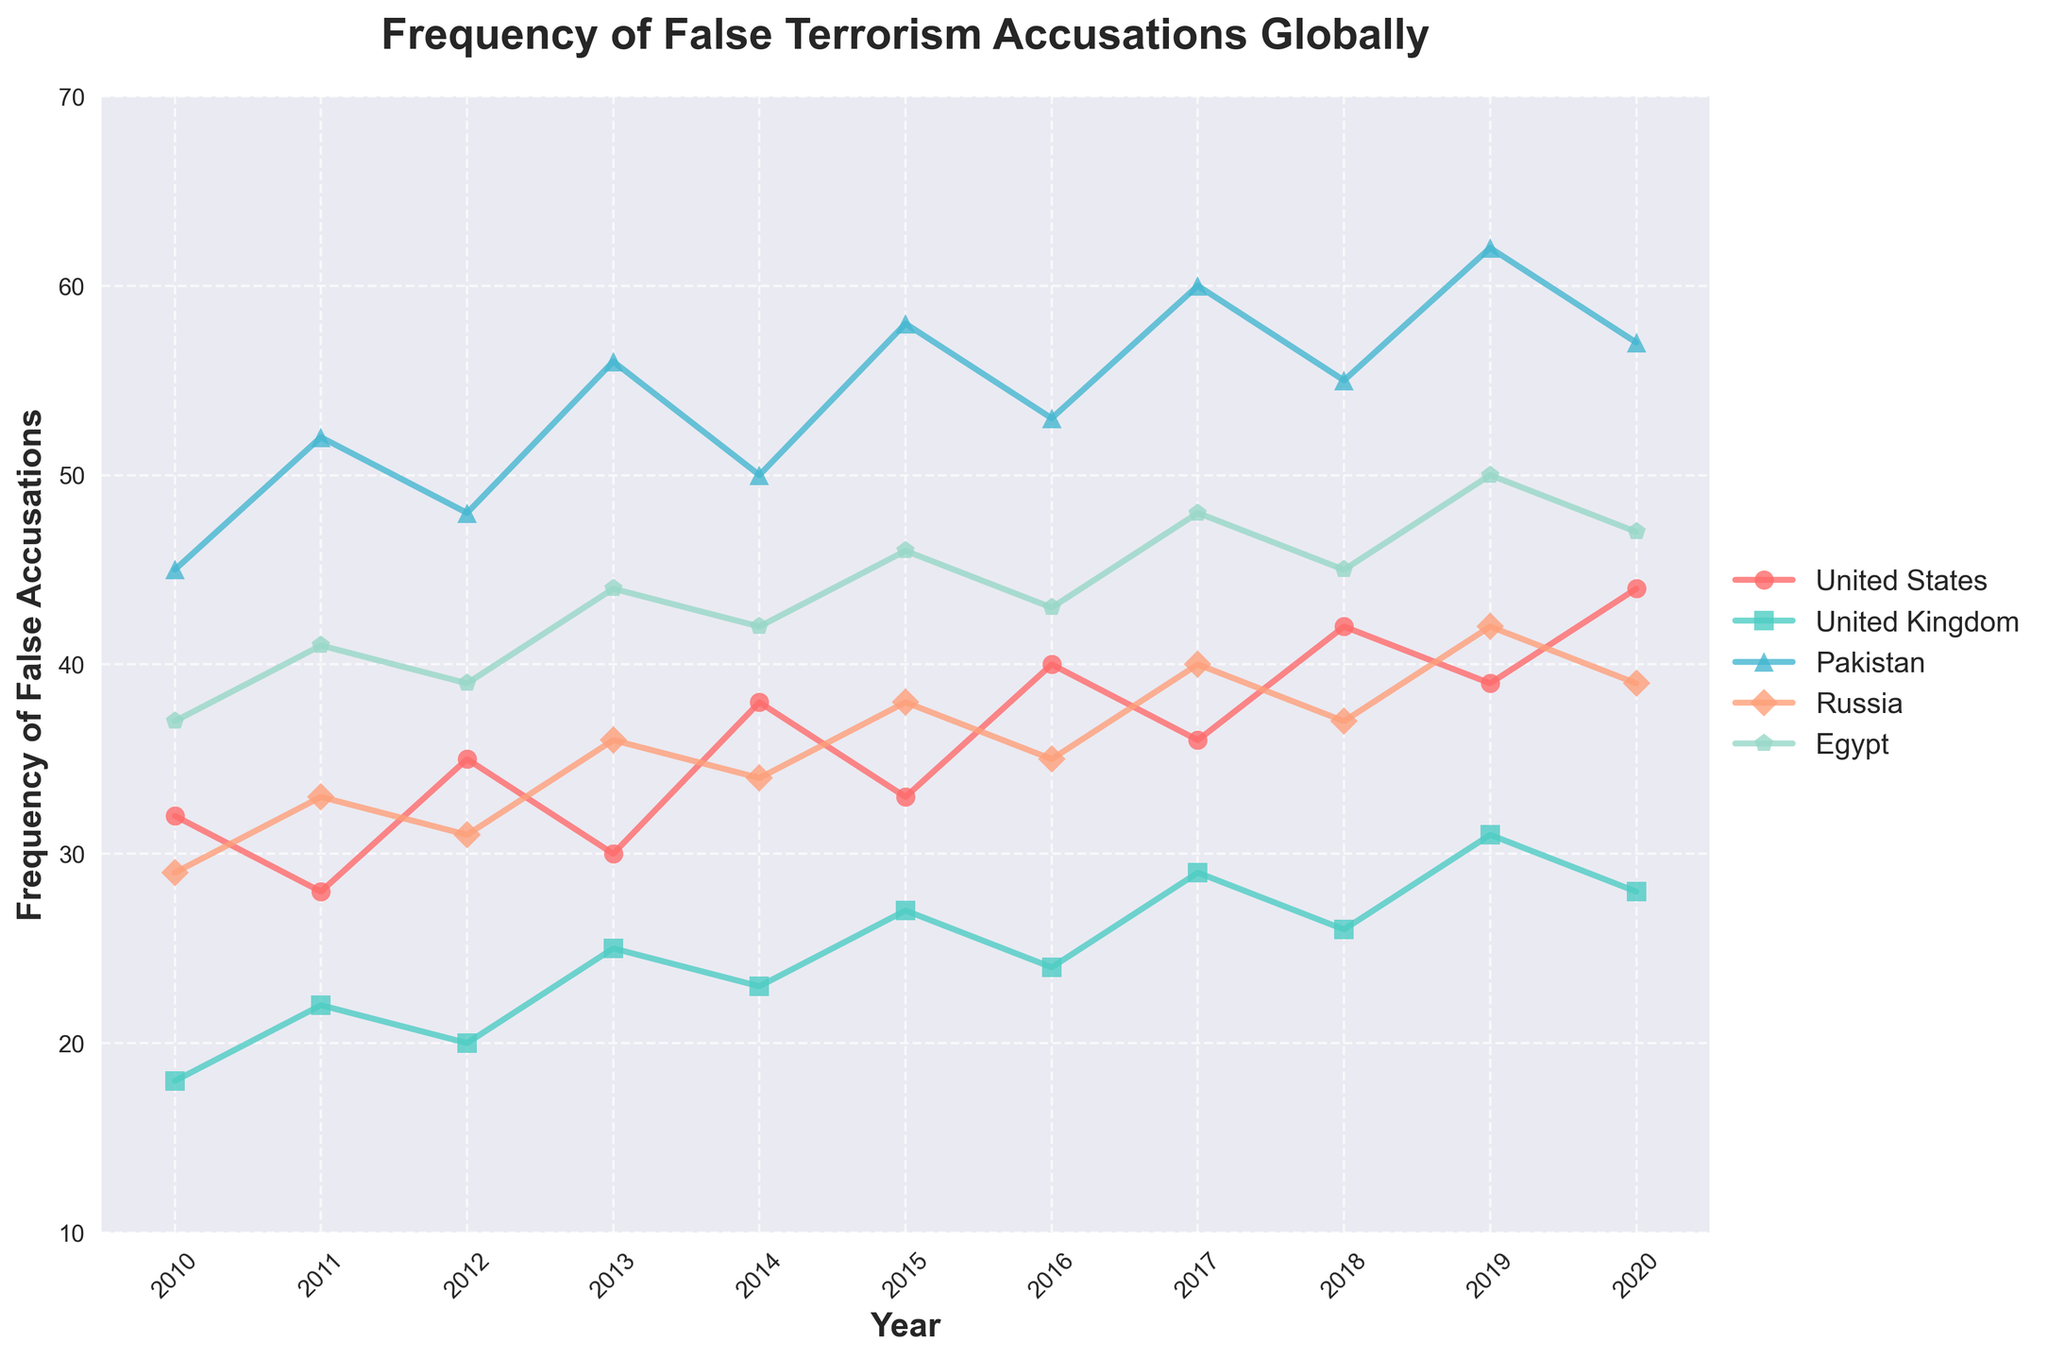Which country showed the highest frequency of false terrorism accusations in 2019? First, identify the year 2019 on the x-axis. Then, look for the highest point among the different colored lines associated with the data for each country in that year. The country with the highest peak for 2019 is Pakistan.
Answer: Pakistan Which country had a decrease in the frequency of false accusations from 2010 to 2011? Identify the positions of the data points for 2010 and 2011 for each country. Check if there is a decrease in the y-coordinates between these years. The United States shows this decrease from 32 to 28.
Answer: United States Which two countries have intersecting lines around 2015? Look for where two different colored lines cross each other near the year 2015. The lines for the United Kingdom and Russia intersect around this time.
Answer: United Kingdom and Russia What is the average frequency of false accusations for the United States over the ten-year period? Sum the frequencies of false accusations for the United States from 2010 to 2020 and divide by 11. The sum is 397, and the average is 397/11.
Answer: 36.09 Which country had the most significant increase in false accusations from 2010 to 2020? Compare the difference in y-coordinates between 2010 and 2020 for each country. Pakistan shows the most significant increase from 45 to 57, which is a 12-point increase.
Answer: Pakistan In which year did Egypt experience the highest number of false accusations? Identify the highest point along the line representing Egypt and note the corresponding year on the x-axis. The peak for Egypt is in 2019 with a count of 50.
Answer: 2019 What was the frequency difference between the United States and the United Kingdom in 2017? Locate the frequencies for both countries in 2017 and subtract the United Kingdom’s value from the United States’ value. The difference is 36 - 29.
Answer: 7 Which country has a consistently upward trend in the frequency of false accusations from 2010 to 2020? Examine the slope of the lines for all countries from 2010 to 2020. The United States consistently shows an upward trend.
Answer: United States Between 2016 and 2017, which country had the largest drop in the frequency of false accusations? Check the drop in y-coordinates between 2016 and 2017 for each country. The United States had a drop from 40 to 36, which is a 4-point drop.
Answer: United States What is the total frequency of false accusations for Russia, summed over the ten-year period? Add up the frequencies for Russia between 2010 and 2020. The total is 29 + 33 + 31 + 36 + 34 + 38 + 35 + 40 + 37 + 42 + 39 = 394.
Answer: 394 